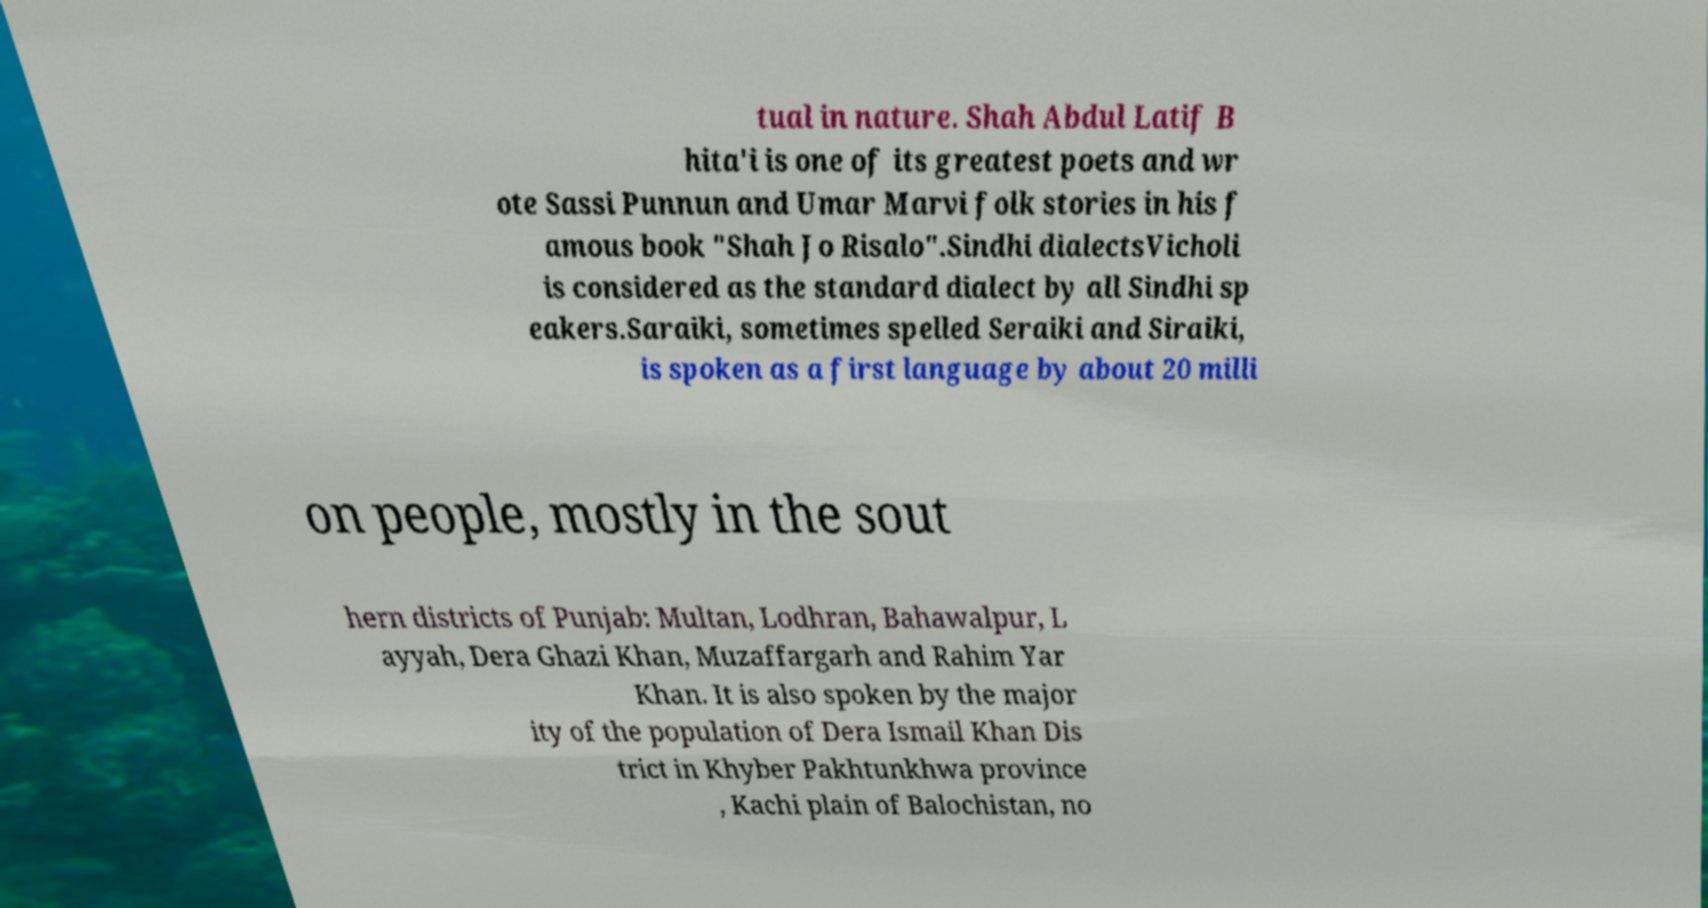Please read and relay the text visible in this image. What does it say? tual in nature. Shah Abdul Latif B hita'i is one of its greatest poets and wr ote Sassi Punnun and Umar Marvi folk stories in his f amous book "Shah Jo Risalo".Sindhi dialectsVicholi is considered as the standard dialect by all Sindhi sp eakers.Saraiki, sometimes spelled Seraiki and Siraiki, is spoken as a first language by about 20 milli on people, mostly in the sout hern districts of Punjab: Multan, Lodhran, Bahawalpur, L ayyah, Dera Ghazi Khan, Muzaffargarh and Rahim Yar Khan. It is also spoken by the major ity of the population of Dera Ismail Khan Dis trict in Khyber Pakhtunkhwa province , Kachi plain of Balochistan, no 